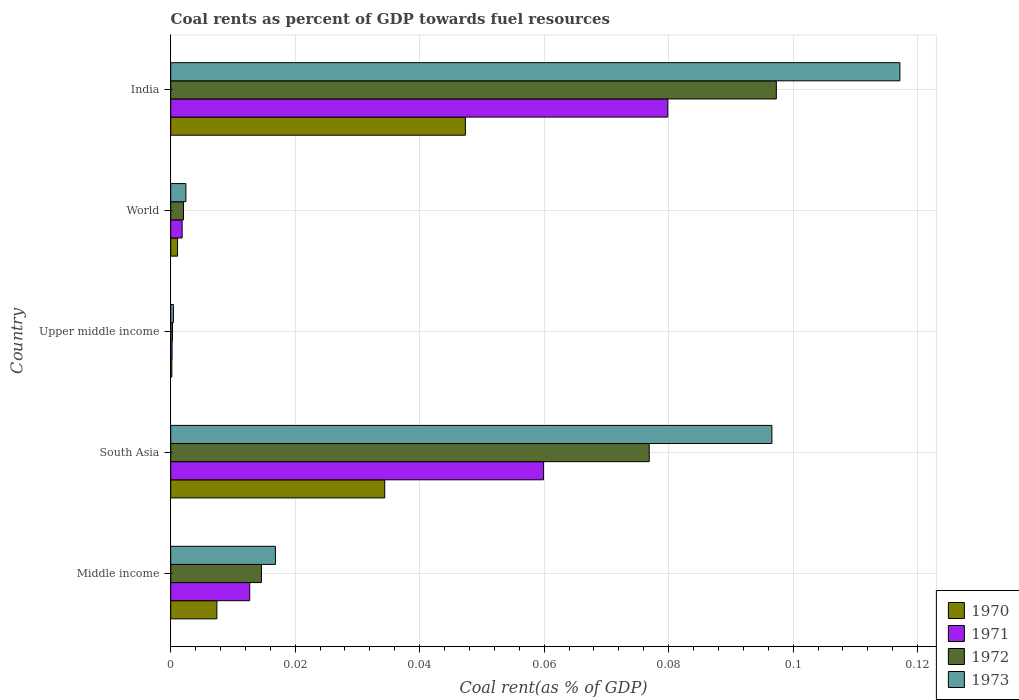How many different coloured bars are there?
Give a very brief answer. 4. Are the number of bars on each tick of the Y-axis equal?
Ensure brevity in your answer.  Yes. How many bars are there on the 2nd tick from the top?
Ensure brevity in your answer.  4. How many bars are there on the 1st tick from the bottom?
Provide a succinct answer. 4. What is the label of the 4th group of bars from the top?
Your response must be concise. South Asia. What is the coal rent in 1973 in South Asia?
Make the answer very short. 0.1. Across all countries, what is the maximum coal rent in 1973?
Your answer should be compact. 0.12. Across all countries, what is the minimum coal rent in 1973?
Provide a short and direct response. 0. In which country was the coal rent in 1970 minimum?
Your answer should be very brief. Upper middle income. What is the total coal rent in 1971 in the graph?
Provide a succinct answer. 0.15. What is the difference between the coal rent in 1970 in India and that in South Asia?
Your answer should be very brief. 0.01. What is the difference between the coal rent in 1972 in Middle income and the coal rent in 1971 in World?
Your answer should be very brief. 0.01. What is the average coal rent in 1972 per country?
Make the answer very short. 0.04. What is the difference between the coal rent in 1973 and coal rent in 1970 in World?
Keep it short and to the point. 0. In how many countries, is the coal rent in 1972 greater than 0.10400000000000001 %?
Make the answer very short. 0. What is the ratio of the coal rent in 1971 in Middle income to that in Upper middle income?
Keep it short and to the point. 58.01. Is the coal rent in 1972 in Middle income less than that in World?
Give a very brief answer. No. What is the difference between the highest and the second highest coal rent in 1973?
Make the answer very short. 0.02. What is the difference between the highest and the lowest coal rent in 1972?
Offer a very short reply. 0.1. In how many countries, is the coal rent in 1973 greater than the average coal rent in 1973 taken over all countries?
Ensure brevity in your answer.  2. Is the sum of the coal rent in 1970 in Middle income and Upper middle income greater than the maximum coal rent in 1971 across all countries?
Provide a short and direct response. No. What does the 2nd bar from the top in South Asia represents?
Your answer should be compact. 1972. What does the 2nd bar from the bottom in South Asia represents?
Make the answer very short. 1971. Are the values on the major ticks of X-axis written in scientific E-notation?
Your answer should be compact. No. How many legend labels are there?
Keep it short and to the point. 4. How are the legend labels stacked?
Provide a short and direct response. Vertical. What is the title of the graph?
Make the answer very short. Coal rents as percent of GDP towards fuel resources. What is the label or title of the X-axis?
Your response must be concise. Coal rent(as % of GDP). What is the label or title of the Y-axis?
Your answer should be very brief. Country. What is the Coal rent(as % of GDP) in 1970 in Middle income?
Your response must be concise. 0.01. What is the Coal rent(as % of GDP) in 1971 in Middle income?
Ensure brevity in your answer.  0.01. What is the Coal rent(as % of GDP) of 1972 in Middle income?
Provide a short and direct response. 0.01. What is the Coal rent(as % of GDP) in 1973 in Middle income?
Provide a short and direct response. 0.02. What is the Coal rent(as % of GDP) in 1970 in South Asia?
Your response must be concise. 0.03. What is the Coal rent(as % of GDP) in 1971 in South Asia?
Offer a very short reply. 0.06. What is the Coal rent(as % of GDP) in 1972 in South Asia?
Ensure brevity in your answer.  0.08. What is the Coal rent(as % of GDP) in 1973 in South Asia?
Your response must be concise. 0.1. What is the Coal rent(as % of GDP) in 1970 in Upper middle income?
Your response must be concise. 0. What is the Coal rent(as % of GDP) of 1971 in Upper middle income?
Your answer should be very brief. 0. What is the Coal rent(as % of GDP) of 1972 in Upper middle income?
Keep it short and to the point. 0. What is the Coal rent(as % of GDP) of 1973 in Upper middle income?
Provide a succinct answer. 0. What is the Coal rent(as % of GDP) of 1970 in World?
Give a very brief answer. 0. What is the Coal rent(as % of GDP) in 1971 in World?
Your answer should be compact. 0. What is the Coal rent(as % of GDP) of 1972 in World?
Ensure brevity in your answer.  0. What is the Coal rent(as % of GDP) of 1973 in World?
Offer a terse response. 0. What is the Coal rent(as % of GDP) in 1970 in India?
Offer a very short reply. 0.05. What is the Coal rent(as % of GDP) in 1971 in India?
Ensure brevity in your answer.  0.08. What is the Coal rent(as % of GDP) in 1972 in India?
Keep it short and to the point. 0.1. What is the Coal rent(as % of GDP) of 1973 in India?
Provide a succinct answer. 0.12. Across all countries, what is the maximum Coal rent(as % of GDP) of 1970?
Offer a very short reply. 0.05. Across all countries, what is the maximum Coal rent(as % of GDP) of 1971?
Provide a short and direct response. 0.08. Across all countries, what is the maximum Coal rent(as % of GDP) in 1972?
Offer a very short reply. 0.1. Across all countries, what is the maximum Coal rent(as % of GDP) in 1973?
Provide a short and direct response. 0.12. Across all countries, what is the minimum Coal rent(as % of GDP) of 1970?
Offer a very short reply. 0. Across all countries, what is the minimum Coal rent(as % of GDP) in 1971?
Provide a short and direct response. 0. Across all countries, what is the minimum Coal rent(as % of GDP) in 1972?
Ensure brevity in your answer.  0. Across all countries, what is the minimum Coal rent(as % of GDP) in 1973?
Your answer should be very brief. 0. What is the total Coal rent(as % of GDP) of 1970 in the graph?
Make the answer very short. 0.09. What is the total Coal rent(as % of GDP) of 1971 in the graph?
Keep it short and to the point. 0.15. What is the total Coal rent(as % of GDP) in 1972 in the graph?
Give a very brief answer. 0.19. What is the total Coal rent(as % of GDP) of 1973 in the graph?
Make the answer very short. 0.23. What is the difference between the Coal rent(as % of GDP) in 1970 in Middle income and that in South Asia?
Your answer should be very brief. -0.03. What is the difference between the Coal rent(as % of GDP) in 1971 in Middle income and that in South Asia?
Make the answer very short. -0.05. What is the difference between the Coal rent(as % of GDP) in 1972 in Middle income and that in South Asia?
Your answer should be compact. -0.06. What is the difference between the Coal rent(as % of GDP) in 1973 in Middle income and that in South Asia?
Offer a very short reply. -0.08. What is the difference between the Coal rent(as % of GDP) in 1970 in Middle income and that in Upper middle income?
Your response must be concise. 0.01. What is the difference between the Coal rent(as % of GDP) of 1971 in Middle income and that in Upper middle income?
Offer a terse response. 0.01. What is the difference between the Coal rent(as % of GDP) in 1972 in Middle income and that in Upper middle income?
Provide a succinct answer. 0.01. What is the difference between the Coal rent(as % of GDP) of 1973 in Middle income and that in Upper middle income?
Make the answer very short. 0.02. What is the difference between the Coal rent(as % of GDP) of 1970 in Middle income and that in World?
Ensure brevity in your answer.  0.01. What is the difference between the Coal rent(as % of GDP) in 1971 in Middle income and that in World?
Ensure brevity in your answer.  0.01. What is the difference between the Coal rent(as % of GDP) in 1972 in Middle income and that in World?
Your answer should be very brief. 0.01. What is the difference between the Coal rent(as % of GDP) in 1973 in Middle income and that in World?
Your response must be concise. 0.01. What is the difference between the Coal rent(as % of GDP) of 1970 in Middle income and that in India?
Provide a short and direct response. -0.04. What is the difference between the Coal rent(as % of GDP) of 1971 in Middle income and that in India?
Keep it short and to the point. -0.07. What is the difference between the Coal rent(as % of GDP) in 1972 in Middle income and that in India?
Your answer should be very brief. -0.08. What is the difference between the Coal rent(as % of GDP) of 1973 in Middle income and that in India?
Keep it short and to the point. -0.1. What is the difference between the Coal rent(as % of GDP) of 1970 in South Asia and that in Upper middle income?
Offer a terse response. 0.03. What is the difference between the Coal rent(as % of GDP) of 1971 in South Asia and that in Upper middle income?
Provide a succinct answer. 0.06. What is the difference between the Coal rent(as % of GDP) in 1972 in South Asia and that in Upper middle income?
Offer a terse response. 0.08. What is the difference between the Coal rent(as % of GDP) in 1973 in South Asia and that in Upper middle income?
Offer a terse response. 0.1. What is the difference between the Coal rent(as % of GDP) in 1970 in South Asia and that in World?
Offer a terse response. 0.03. What is the difference between the Coal rent(as % of GDP) of 1971 in South Asia and that in World?
Ensure brevity in your answer.  0.06. What is the difference between the Coal rent(as % of GDP) in 1972 in South Asia and that in World?
Your answer should be compact. 0.07. What is the difference between the Coal rent(as % of GDP) of 1973 in South Asia and that in World?
Provide a short and direct response. 0.09. What is the difference between the Coal rent(as % of GDP) in 1970 in South Asia and that in India?
Your response must be concise. -0.01. What is the difference between the Coal rent(as % of GDP) in 1971 in South Asia and that in India?
Your answer should be compact. -0.02. What is the difference between the Coal rent(as % of GDP) in 1972 in South Asia and that in India?
Provide a succinct answer. -0.02. What is the difference between the Coal rent(as % of GDP) in 1973 in South Asia and that in India?
Keep it short and to the point. -0.02. What is the difference between the Coal rent(as % of GDP) of 1970 in Upper middle income and that in World?
Ensure brevity in your answer.  -0. What is the difference between the Coal rent(as % of GDP) of 1971 in Upper middle income and that in World?
Offer a terse response. -0. What is the difference between the Coal rent(as % of GDP) in 1972 in Upper middle income and that in World?
Your answer should be very brief. -0. What is the difference between the Coal rent(as % of GDP) of 1973 in Upper middle income and that in World?
Offer a terse response. -0. What is the difference between the Coal rent(as % of GDP) in 1970 in Upper middle income and that in India?
Provide a succinct answer. -0.05. What is the difference between the Coal rent(as % of GDP) of 1971 in Upper middle income and that in India?
Your answer should be compact. -0.08. What is the difference between the Coal rent(as % of GDP) in 1972 in Upper middle income and that in India?
Provide a succinct answer. -0.1. What is the difference between the Coal rent(as % of GDP) in 1973 in Upper middle income and that in India?
Your answer should be compact. -0.12. What is the difference between the Coal rent(as % of GDP) in 1970 in World and that in India?
Give a very brief answer. -0.05. What is the difference between the Coal rent(as % of GDP) in 1971 in World and that in India?
Provide a short and direct response. -0.08. What is the difference between the Coal rent(as % of GDP) of 1972 in World and that in India?
Ensure brevity in your answer.  -0.1. What is the difference between the Coal rent(as % of GDP) of 1973 in World and that in India?
Ensure brevity in your answer.  -0.11. What is the difference between the Coal rent(as % of GDP) of 1970 in Middle income and the Coal rent(as % of GDP) of 1971 in South Asia?
Make the answer very short. -0.05. What is the difference between the Coal rent(as % of GDP) in 1970 in Middle income and the Coal rent(as % of GDP) in 1972 in South Asia?
Make the answer very short. -0.07. What is the difference between the Coal rent(as % of GDP) in 1970 in Middle income and the Coal rent(as % of GDP) in 1973 in South Asia?
Give a very brief answer. -0.09. What is the difference between the Coal rent(as % of GDP) of 1971 in Middle income and the Coal rent(as % of GDP) of 1972 in South Asia?
Make the answer very short. -0.06. What is the difference between the Coal rent(as % of GDP) in 1971 in Middle income and the Coal rent(as % of GDP) in 1973 in South Asia?
Provide a succinct answer. -0.08. What is the difference between the Coal rent(as % of GDP) of 1972 in Middle income and the Coal rent(as % of GDP) of 1973 in South Asia?
Provide a succinct answer. -0.08. What is the difference between the Coal rent(as % of GDP) of 1970 in Middle income and the Coal rent(as % of GDP) of 1971 in Upper middle income?
Give a very brief answer. 0.01. What is the difference between the Coal rent(as % of GDP) in 1970 in Middle income and the Coal rent(as % of GDP) in 1972 in Upper middle income?
Ensure brevity in your answer.  0.01. What is the difference between the Coal rent(as % of GDP) of 1970 in Middle income and the Coal rent(as % of GDP) of 1973 in Upper middle income?
Offer a very short reply. 0.01. What is the difference between the Coal rent(as % of GDP) in 1971 in Middle income and the Coal rent(as % of GDP) in 1972 in Upper middle income?
Make the answer very short. 0.01. What is the difference between the Coal rent(as % of GDP) in 1971 in Middle income and the Coal rent(as % of GDP) in 1973 in Upper middle income?
Ensure brevity in your answer.  0.01. What is the difference between the Coal rent(as % of GDP) of 1972 in Middle income and the Coal rent(as % of GDP) of 1973 in Upper middle income?
Your answer should be compact. 0.01. What is the difference between the Coal rent(as % of GDP) of 1970 in Middle income and the Coal rent(as % of GDP) of 1971 in World?
Provide a short and direct response. 0.01. What is the difference between the Coal rent(as % of GDP) of 1970 in Middle income and the Coal rent(as % of GDP) of 1972 in World?
Give a very brief answer. 0.01. What is the difference between the Coal rent(as % of GDP) of 1970 in Middle income and the Coal rent(as % of GDP) of 1973 in World?
Offer a very short reply. 0.01. What is the difference between the Coal rent(as % of GDP) of 1971 in Middle income and the Coal rent(as % of GDP) of 1972 in World?
Provide a short and direct response. 0.01. What is the difference between the Coal rent(as % of GDP) of 1971 in Middle income and the Coal rent(as % of GDP) of 1973 in World?
Offer a terse response. 0.01. What is the difference between the Coal rent(as % of GDP) of 1972 in Middle income and the Coal rent(as % of GDP) of 1973 in World?
Provide a short and direct response. 0.01. What is the difference between the Coal rent(as % of GDP) of 1970 in Middle income and the Coal rent(as % of GDP) of 1971 in India?
Your answer should be compact. -0.07. What is the difference between the Coal rent(as % of GDP) in 1970 in Middle income and the Coal rent(as % of GDP) in 1972 in India?
Offer a terse response. -0.09. What is the difference between the Coal rent(as % of GDP) of 1970 in Middle income and the Coal rent(as % of GDP) of 1973 in India?
Offer a terse response. -0.11. What is the difference between the Coal rent(as % of GDP) of 1971 in Middle income and the Coal rent(as % of GDP) of 1972 in India?
Offer a very short reply. -0.08. What is the difference between the Coal rent(as % of GDP) of 1971 in Middle income and the Coal rent(as % of GDP) of 1973 in India?
Your answer should be very brief. -0.1. What is the difference between the Coal rent(as % of GDP) of 1972 in Middle income and the Coal rent(as % of GDP) of 1973 in India?
Provide a succinct answer. -0.1. What is the difference between the Coal rent(as % of GDP) of 1970 in South Asia and the Coal rent(as % of GDP) of 1971 in Upper middle income?
Your answer should be compact. 0.03. What is the difference between the Coal rent(as % of GDP) in 1970 in South Asia and the Coal rent(as % of GDP) in 1972 in Upper middle income?
Your answer should be compact. 0.03. What is the difference between the Coal rent(as % of GDP) of 1970 in South Asia and the Coal rent(as % of GDP) of 1973 in Upper middle income?
Make the answer very short. 0.03. What is the difference between the Coal rent(as % of GDP) in 1971 in South Asia and the Coal rent(as % of GDP) in 1972 in Upper middle income?
Provide a short and direct response. 0.06. What is the difference between the Coal rent(as % of GDP) in 1971 in South Asia and the Coal rent(as % of GDP) in 1973 in Upper middle income?
Provide a succinct answer. 0.06. What is the difference between the Coal rent(as % of GDP) of 1972 in South Asia and the Coal rent(as % of GDP) of 1973 in Upper middle income?
Provide a succinct answer. 0.08. What is the difference between the Coal rent(as % of GDP) of 1970 in South Asia and the Coal rent(as % of GDP) of 1971 in World?
Provide a short and direct response. 0.03. What is the difference between the Coal rent(as % of GDP) of 1970 in South Asia and the Coal rent(as % of GDP) of 1972 in World?
Keep it short and to the point. 0.03. What is the difference between the Coal rent(as % of GDP) of 1970 in South Asia and the Coal rent(as % of GDP) of 1973 in World?
Make the answer very short. 0.03. What is the difference between the Coal rent(as % of GDP) in 1971 in South Asia and the Coal rent(as % of GDP) in 1972 in World?
Make the answer very short. 0.06. What is the difference between the Coal rent(as % of GDP) in 1971 in South Asia and the Coal rent(as % of GDP) in 1973 in World?
Give a very brief answer. 0.06. What is the difference between the Coal rent(as % of GDP) of 1972 in South Asia and the Coal rent(as % of GDP) of 1973 in World?
Your answer should be compact. 0.07. What is the difference between the Coal rent(as % of GDP) in 1970 in South Asia and the Coal rent(as % of GDP) in 1971 in India?
Your response must be concise. -0.05. What is the difference between the Coal rent(as % of GDP) of 1970 in South Asia and the Coal rent(as % of GDP) of 1972 in India?
Your answer should be compact. -0.06. What is the difference between the Coal rent(as % of GDP) in 1970 in South Asia and the Coal rent(as % of GDP) in 1973 in India?
Your answer should be compact. -0.08. What is the difference between the Coal rent(as % of GDP) of 1971 in South Asia and the Coal rent(as % of GDP) of 1972 in India?
Provide a succinct answer. -0.04. What is the difference between the Coal rent(as % of GDP) in 1971 in South Asia and the Coal rent(as % of GDP) in 1973 in India?
Offer a very short reply. -0.06. What is the difference between the Coal rent(as % of GDP) of 1972 in South Asia and the Coal rent(as % of GDP) of 1973 in India?
Provide a short and direct response. -0.04. What is the difference between the Coal rent(as % of GDP) of 1970 in Upper middle income and the Coal rent(as % of GDP) of 1971 in World?
Offer a terse response. -0. What is the difference between the Coal rent(as % of GDP) in 1970 in Upper middle income and the Coal rent(as % of GDP) in 1972 in World?
Your answer should be compact. -0. What is the difference between the Coal rent(as % of GDP) of 1970 in Upper middle income and the Coal rent(as % of GDP) of 1973 in World?
Your answer should be very brief. -0. What is the difference between the Coal rent(as % of GDP) of 1971 in Upper middle income and the Coal rent(as % of GDP) of 1972 in World?
Provide a succinct answer. -0. What is the difference between the Coal rent(as % of GDP) in 1971 in Upper middle income and the Coal rent(as % of GDP) in 1973 in World?
Your answer should be compact. -0. What is the difference between the Coal rent(as % of GDP) in 1972 in Upper middle income and the Coal rent(as % of GDP) in 1973 in World?
Give a very brief answer. -0. What is the difference between the Coal rent(as % of GDP) in 1970 in Upper middle income and the Coal rent(as % of GDP) in 1971 in India?
Keep it short and to the point. -0.08. What is the difference between the Coal rent(as % of GDP) of 1970 in Upper middle income and the Coal rent(as % of GDP) of 1972 in India?
Give a very brief answer. -0.1. What is the difference between the Coal rent(as % of GDP) in 1970 in Upper middle income and the Coal rent(as % of GDP) in 1973 in India?
Make the answer very short. -0.12. What is the difference between the Coal rent(as % of GDP) of 1971 in Upper middle income and the Coal rent(as % of GDP) of 1972 in India?
Provide a succinct answer. -0.1. What is the difference between the Coal rent(as % of GDP) in 1971 in Upper middle income and the Coal rent(as % of GDP) in 1973 in India?
Offer a very short reply. -0.12. What is the difference between the Coal rent(as % of GDP) in 1972 in Upper middle income and the Coal rent(as % of GDP) in 1973 in India?
Keep it short and to the point. -0.12. What is the difference between the Coal rent(as % of GDP) of 1970 in World and the Coal rent(as % of GDP) of 1971 in India?
Offer a very short reply. -0.08. What is the difference between the Coal rent(as % of GDP) of 1970 in World and the Coal rent(as % of GDP) of 1972 in India?
Your answer should be compact. -0.1. What is the difference between the Coal rent(as % of GDP) of 1970 in World and the Coal rent(as % of GDP) of 1973 in India?
Give a very brief answer. -0.12. What is the difference between the Coal rent(as % of GDP) in 1971 in World and the Coal rent(as % of GDP) in 1972 in India?
Provide a short and direct response. -0.1. What is the difference between the Coal rent(as % of GDP) of 1971 in World and the Coal rent(as % of GDP) of 1973 in India?
Make the answer very short. -0.12. What is the difference between the Coal rent(as % of GDP) of 1972 in World and the Coal rent(as % of GDP) of 1973 in India?
Your answer should be very brief. -0.12. What is the average Coal rent(as % of GDP) of 1970 per country?
Offer a very short reply. 0.02. What is the average Coal rent(as % of GDP) of 1971 per country?
Your answer should be compact. 0.03. What is the average Coal rent(as % of GDP) of 1972 per country?
Provide a short and direct response. 0.04. What is the average Coal rent(as % of GDP) in 1973 per country?
Provide a succinct answer. 0.05. What is the difference between the Coal rent(as % of GDP) in 1970 and Coal rent(as % of GDP) in 1971 in Middle income?
Offer a terse response. -0.01. What is the difference between the Coal rent(as % of GDP) in 1970 and Coal rent(as % of GDP) in 1972 in Middle income?
Give a very brief answer. -0.01. What is the difference between the Coal rent(as % of GDP) of 1970 and Coal rent(as % of GDP) of 1973 in Middle income?
Give a very brief answer. -0.01. What is the difference between the Coal rent(as % of GDP) in 1971 and Coal rent(as % of GDP) in 1972 in Middle income?
Provide a succinct answer. -0. What is the difference between the Coal rent(as % of GDP) in 1971 and Coal rent(as % of GDP) in 1973 in Middle income?
Provide a short and direct response. -0. What is the difference between the Coal rent(as % of GDP) of 1972 and Coal rent(as % of GDP) of 1973 in Middle income?
Keep it short and to the point. -0. What is the difference between the Coal rent(as % of GDP) of 1970 and Coal rent(as % of GDP) of 1971 in South Asia?
Your response must be concise. -0.03. What is the difference between the Coal rent(as % of GDP) in 1970 and Coal rent(as % of GDP) in 1972 in South Asia?
Give a very brief answer. -0.04. What is the difference between the Coal rent(as % of GDP) in 1970 and Coal rent(as % of GDP) in 1973 in South Asia?
Keep it short and to the point. -0.06. What is the difference between the Coal rent(as % of GDP) in 1971 and Coal rent(as % of GDP) in 1972 in South Asia?
Ensure brevity in your answer.  -0.02. What is the difference between the Coal rent(as % of GDP) of 1971 and Coal rent(as % of GDP) of 1973 in South Asia?
Offer a very short reply. -0.04. What is the difference between the Coal rent(as % of GDP) of 1972 and Coal rent(as % of GDP) of 1973 in South Asia?
Offer a very short reply. -0.02. What is the difference between the Coal rent(as % of GDP) of 1970 and Coal rent(as % of GDP) of 1971 in Upper middle income?
Keep it short and to the point. -0. What is the difference between the Coal rent(as % of GDP) in 1970 and Coal rent(as % of GDP) in 1972 in Upper middle income?
Keep it short and to the point. -0. What is the difference between the Coal rent(as % of GDP) of 1970 and Coal rent(as % of GDP) of 1973 in Upper middle income?
Provide a succinct answer. -0. What is the difference between the Coal rent(as % of GDP) in 1971 and Coal rent(as % of GDP) in 1972 in Upper middle income?
Ensure brevity in your answer.  -0. What is the difference between the Coal rent(as % of GDP) in 1971 and Coal rent(as % of GDP) in 1973 in Upper middle income?
Give a very brief answer. -0. What is the difference between the Coal rent(as % of GDP) in 1972 and Coal rent(as % of GDP) in 1973 in Upper middle income?
Offer a very short reply. -0. What is the difference between the Coal rent(as % of GDP) in 1970 and Coal rent(as % of GDP) in 1971 in World?
Offer a very short reply. -0. What is the difference between the Coal rent(as % of GDP) of 1970 and Coal rent(as % of GDP) of 1972 in World?
Provide a short and direct response. -0. What is the difference between the Coal rent(as % of GDP) in 1970 and Coal rent(as % of GDP) in 1973 in World?
Your answer should be very brief. -0. What is the difference between the Coal rent(as % of GDP) of 1971 and Coal rent(as % of GDP) of 1972 in World?
Your answer should be compact. -0. What is the difference between the Coal rent(as % of GDP) of 1971 and Coal rent(as % of GDP) of 1973 in World?
Provide a short and direct response. -0. What is the difference between the Coal rent(as % of GDP) of 1972 and Coal rent(as % of GDP) of 1973 in World?
Offer a terse response. -0. What is the difference between the Coal rent(as % of GDP) of 1970 and Coal rent(as % of GDP) of 1971 in India?
Make the answer very short. -0.03. What is the difference between the Coal rent(as % of GDP) in 1970 and Coal rent(as % of GDP) in 1973 in India?
Ensure brevity in your answer.  -0.07. What is the difference between the Coal rent(as % of GDP) in 1971 and Coal rent(as % of GDP) in 1972 in India?
Offer a very short reply. -0.02. What is the difference between the Coal rent(as % of GDP) of 1971 and Coal rent(as % of GDP) of 1973 in India?
Offer a terse response. -0.04. What is the difference between the Coal rent(as % of GDP) of 1972 and Coal rent(as % of GDP) of 1973 in India?
Your answer should be very brief. -0.02. What is the ratio of the Coal rent(as % of GDP) in 1970 in Middle income to that in South Asia?
Offer a terse response. 0.22. What is the ratio of the Coal rent(as % of GDP) in 1971 in Middle income to that in South Asia?
Offer a terse response. 0.21. What is the ratio of the Coal rent(as % of GDP) in 1972 in Middle income to that in South Asia?
Provide a short and direct response. 0.19. What is the ratio of the Coal rent(as % of GDP) in 1973 in Middle income to that in South Asia?
Your response must be concise. 0.17. What is the ratio of the Coal rent(as % of GDP) of 1970 in Middle income to that in Upper middle income?
Ensure brevity in your answer.  40.36. What is the ratio of the Coal rent(as % of GDP) of 1971 in Middle income to that in Upper middle income?
Give a very brief answer. 58.01. What is the ratio of the Coal rent(as % of GDP) in 1972 in Middle income to that in Upper middle income?
Keep it short and to the point. 51.25. What is the ratio of the Coal rent(as % of GDP) in 1973 in Middle income to that in Upper middle income?
Offer a very short reply. 39.04. What is the ratio of the Coal rent(as % of GDP) in 1970 in Middle income to that in World?
Your answer should be compact. 6.74. What is the ratio of the Coal rent(as % of GDP) of 1971 in Middle income to that in World?
Your answer should be compact. 6.93. What is the ratio of the Coal rent(as % of GDP) in 1972 in Middle income to that in World?
Your response must be concise. 7.09. What is the ratio of the Coal rent(as % of GDP) of 1973 in Middle income to that in World?
Make the answer very short. 6.91. What is the ratio of the Coal rent(as % of GDP) in 1970 in Middle income to that in India?
Your answer should be very brief. 0.16. What is the ratio of the Coal rent(as % of GDP) in 1971 in Middle income to that in India?
Provide a short and direct response. 0.16. What is the ratio of the Coal rent(as % of GDP) of 1972 in Middle income to that in India?
Provide a succinct answer. 0.15. What is the ratio of the Coal rent(as % of GDP) of 1973 in Middle income to that in India?
Make the answer very short. 0.14. What is the ratio of the Coal rent(as % of GDP) in 1970 in South Asia to that in Upper middle income?
Your response must be concise. 187.05. What is the ratio of the Coal rent(as % of GDP) in 1971 in South Asia to that in Upper middle income?
Ensure brevity in your answer.  273.74. What is the ratio of the Coal rent(as % of GDP) in 1972 in South Asia to that in Upper middle income?
Make the answer very short. 270.32. What is the ratio of the Coal rent(as % of GDP) of 1973 in South Asia to that in Upper middle income?
Your response must be concise. 224.18. What is the ratio of the Coal rent(as % of GDP) in 1970 in South Asia to that in World?
Your answer should be very brief. 31.24. What is the ratio of the Coal rent(as % of GDP) of 1971 in South Asia to that in World?
Offer a very short reply. 32.69. What is the ratio of the Coal rent(as % of GDP) of 1972 in South Asia to that in World?
Provide a succinct answer. 37.41. What is the ratio of the Coal rent(as % of GDP) in 1973 in South Asia to that in World?
Ensure brevity in your answer.  39.65. What is the ratio of the Coal rent(as % of GDP) of 1970 in South Asia to that in India?
Give a very brief answer. 0.73. What is the ratio of the Coal rent(as % of GDP) in 1971 in South Asia to that in India?
Offer a very short reply. 0.75. What is the ratio of the Coal rent(as % of GDP) in 1972 in South Asia to that in India?
Provide a succinct answer. 0.79. What is the ratio of the Coal rent(as % of GDP) in 1973 in South Asia to that in India?
Your answer should be compact. 0.82. What is the ratio of the Coal rent(as % of GDP) of 1970 in Upper middle income to that in World?
Make the answer very short. 0.17. What is the ratio of the Coal rent(as % of GDP) of 1971 in Upper middle income to that in World?
Keep it short and to the point. 0.12. What is the ratio of the Coal rent(as % of GDP) in 1972 in Upper middle income to that in World?
Your answer should be compact. 0.14. What is the ratio of the Coal rent(as % of GDP) in 1973 in Upper middle income to that in World?
Offer a very short reply. 0.18. What is the ratio of the Coal rent(as % of GDP) of 1970 in Upper middle income to that in India?
Offer a very short reply. 0. What is the ratio of the Coal rent(as % of GDP) in 1971 in Upper middle income to that in India?
Provide a succinct answer. 0. What is the ratio of the Coal rent(as % of GDP) in 1972 in Upper middle income to that in India?
Provide a short and direct response. 0. What is the ratio of the Coal rent(as % of GDP) of 1973 in Upper middle income to that in India?
Offer a terse response. 0. What is the ratio of the Coal rent(as % of GDP) in 1970 in World to that in India?
Offer a very short reply. 0.02. What is the ratio of the Coal rent(as % of GDP) of 1971 in World to that in India?
Your answer should be compact. 0.02. What is the ratio of the Coal rent(as % of GDP) in 1972 in World to that in India?
Offer a very short reply. 0.02. What is the ratio of the Coal rent(as % of GDP) in 1973 in World to that in India?
Make the answer very short. 0.02. What is the difference between the highest and the second highest Coal rent(as % of GDP) in 1970?
Provide a short and direct response. 0.01. What is the difference between the highest and the second highest Coal rent(as % of GDP) of 1972?
Offer a very short reply. 0.02. What is the difference between the highest and the second highest Coal rent(as % of GDP) in 1973?
Offer a very short reply. 0.02. What is the difference between the highest and the lowest Coal rent(as % of GDP) in 1970?
Your answer should be very brief. 0.05. What is the difference between the highest and the lowest Coal rent(as % of GDP) of 1971?
Give a very brief answer. 0.08. What is the difference between the highest and the lowest Coal rent(as % of GDP) in 1972?
Offer a terse response. 0.1. What is the difference between the highest and the lowest Coal rent(as % of GDP) in 1973?
Keep it short and to the point. 0.12. 